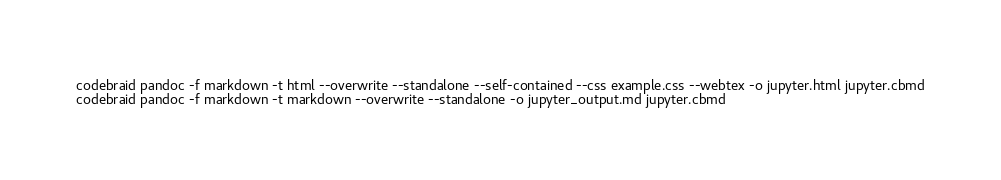<code> <loc_0><loc_0><loc_500><loc_500><_Bash_>codebraid pandoc -f markdown -t html --overwrite --standalone --self-contained --css example.css --webtex -o jupyter.html jupyter.cbmd
codebraid pandoc -f markdown -t markdown --overwrite --standalone -o jupyter_output.md jupyter.cbmd
</code> 